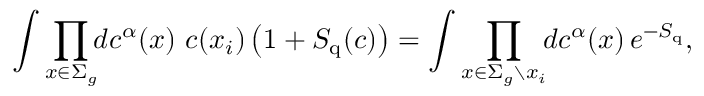<formula> <loc_0><loc_0><loc_500><loc_500>\int \prod _ { x \in \Sigma _ { g } } \, d c ^ { \alpha } ( x ) \, c ( x _ { i } ) \left ( 1 + S _ { q } ( c ) \right ) = \int \prod _ { x \in \Sigma _ { g } \ x _ { i } } \, d c ^ { \alpha } ( x ) \, e ^ { - S _ { q } } ,</formula> 